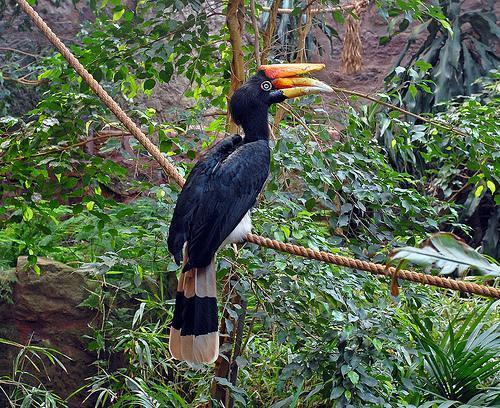How many birds are there?
Give a very brief answer. 1. 